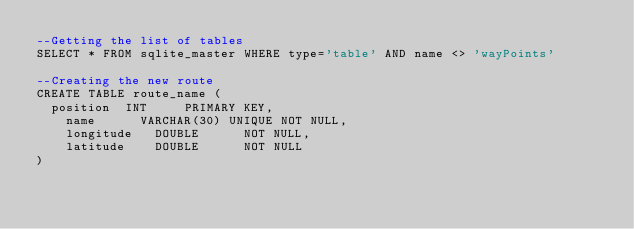<code> <loc_0><loc_0><loc_500><loc_500><_SQL_>--Getting the list of tables
SELECT * FROM sqlite_master WHERE type='table' AND name <> 'wayPoints'

--Creating the new route
CREATE TABLE route_name (
	position	INT			PRIMARY KEY,
    name    	VARCHAR(30) UNIQUE NOT NULL,
    longitude   DOUBLE      NOT NULL,
    latitude    DOUBLE      NOT NULL
)</code> 